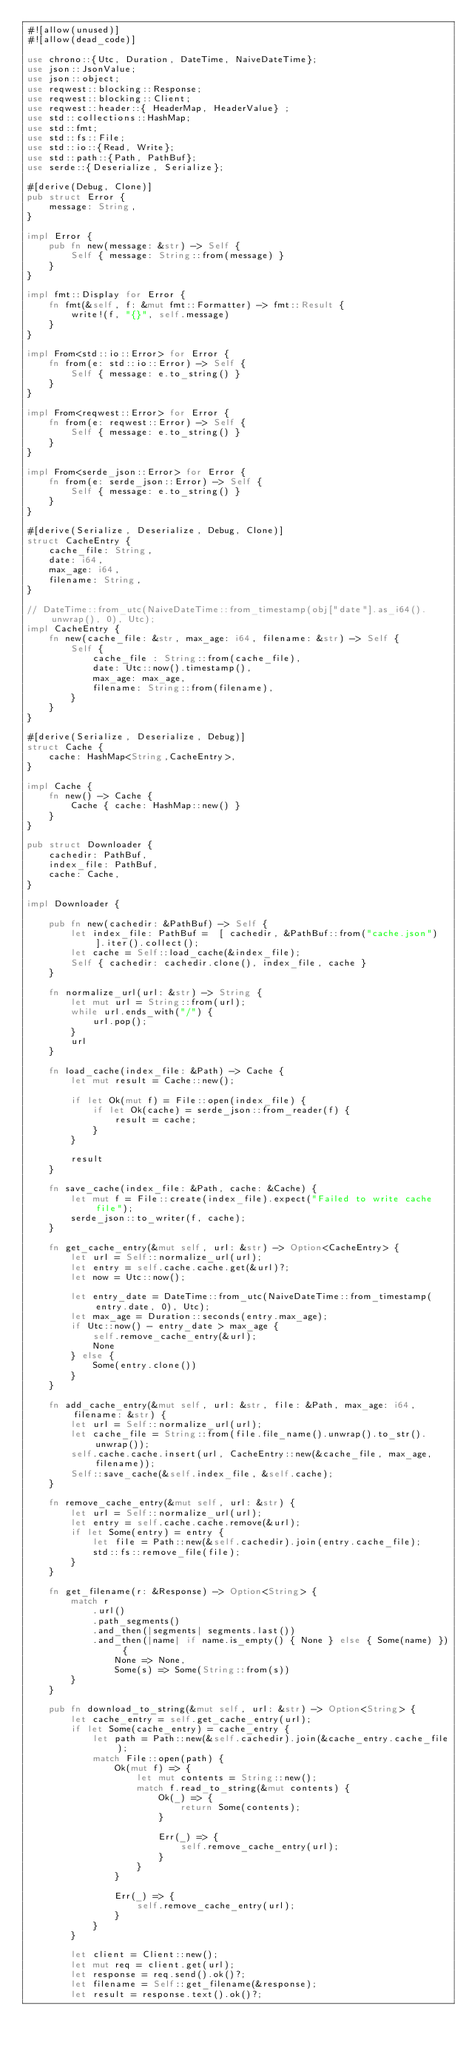Convert code to text. <code><loc_0><loc_0><loc_500><loc_500><_Rust_>#![allow(unused)]
#![allow(dead_code)]

use chrono::{Utc, Duration, DateTime, NaiveDateTime};
use json::JsonValue;
use json::object;
use reqwest::blocking::Response;
use reqwest::blocking::Client;
use reqwest::header::{ HeaderMap, HeaderValue} ;
use std::collections::HashMap;
use std::fmt;
use std::fs::File;
use std::io::{Read, Write};
use std::path::{Path, PathBuf};
use serde::{Deserialize, Serialize};

#[derive(Debug, Clone)]
pub struct Error {
    message: String,
}

impl Error {
    pub fn new(message: &str) -> Self {
        Self { message: String::from(message) }
    }
}

impl fmt::Display for Error {
    fn fmt(&self, f: &mut fmt::Formatter) -> fmt::Result {
        write!(f, "{}", self.message)
    }
}

impl From<std::io::Error> for Error {
    fn from(e: std::io::Error) -> Self {
        Self { message: e.to_string() }
    }
}

impl From<reqwest::Error> for Error {
    fn from(e: reqwest::Error) -> Self {
        Self { message: e.to_string() }
    }
}

impl From<serde_json::Error> for Error {
    fn from(e: serde_json::Error) -> Self {
        Self { message: e.to_string() }
    }
}

#[derive(Serialize, Deserialize, Debug, Clone)]
struct CacheEntry {
    cache_file: String,
    date: i64,
    max_age: i64,
    filename: String,
}

// DateTime::from_utc(NaiveDateTime::from_timestamp(obj["date"].as_i64().unwrap(), 0), Utc);
impl CacheEntry {
    fn new(cache_file: &str, max_age: i64, filename: &str) -> Self {
        Self {
            cache_file : String::from(cache_file),
            date: Utc::now().timestamp(),
            max_age: max_age,
            filename: String::from(filename),
        }
    }
}

#[derive(Serialize, Deserialize, Debug)]
struct Cache {
    cache: HashMap<String,CacheEntry>,
}

impl Cache {
    fn new() -> Cache {
        Cache { cache: HashMap::new() }
    }
}

pub struct Downloader {
    cachedir: PathBuf,
    index_file: PathBuf,
    cache: Cache,
}

impl Downloader {

    pub fn new(cachedir: &PathBuf) -> Self {
        let index_file: PathBuf =  [ cachedir, &PathBuf::from("cache.json") ].iter().collect();
        let cache = Self::load_cache(&index_file);
        Self { cachedir: cachedir.clone(), index_file, cache }
    }
    
    fn normalize_url(url: &str) -> String {
        let mut url = String::from(url);
        while url.ends_with("/") {
            url.pop();
        }
        url
    }

    fn load_cache(index_file: &Path) -> Cache {
        let mut result = Cache::new();

        if let Ok(mut f) = File::open(index_file) {
            if let Ok(cache) = serde_json::from_reader(f) {
                result = cache;
            }
        }

        result
    }

    fn save_cache(index_file: &Path, cache: &Cache) {
        let mut f = File::create(index_file).expect("Failed to write cache file");
        serde_json::to_writer(f, cache);
    }

    fn get_cache_entry(&mut self, url: &str) -> Option<CacheEntry> {
        let url = Self::normalize_url(url);
        let entry = self.cache.cache.get(&url)?;
        let now = Utc::now();

        let entry_date = DateTime::from_utc(NaiveDateTime::from_timestamp(entry.date, 0), Utc);
        let max_age = Duration::seconds(entry.max_age);
        if Utc::now() - entry_date > max_age {
            self.remove_cache_entry(&url);
            None
        } else {
            Some(entry.clone())
        }
    }

    fn add_cache_entry(&mut self, url: &str, file: &Path, max_age: i64, filename: &str) {
        let url = Self::normalize_url(url);
        let cache_file = String::from(file.file_name().unwrap().to_str().unwrap());
        self.cache.cache.insert(url, CacheEntry::new(&cache_file, max_age, filename));
        Self::save_cache(&self.index_file, &self.cache);
    }

    fn remove_cache_entry(&mut self, url: &str) {
        let url = Self::normalize_url(url);
        let entry = self.cache.cache.remove(&url);
        if let Some(entry) = entry {
            let file = Path::new(&self.cachedir).join(entry.cache_file);
            std::fs::remove_file(file);
        }
    }

    fn get_filename(r: &Response) -> Option<String> {
        match r
            .url()
            .path_segments()
            .and_then(|segments| segments.last())
            .and_then(|name| if name.is_empty() { None } else { Some(name) }) {
                None => None,
                Some(s) => Some(String::from(s))
        }
    }

    pub fn download_to_string(&mut self, url: &str) -> Option<String> {
        let cache_entry = self.get_cache_entry(url);
        if let Some(cache_entry) = cache_entry {
            let path = Path::new(&self.cachedir).join(&cache_entry.cache_file);
            match File::open(path) {
                Ok(mut f) => {
                    let mut contents = String::new();
                    match f.read_to_string(&mut contents) {
                        Ok(_) => {
                            return Some(contents);
                        }

                        Err(_) => {
                            self.remove_cache_entry(url);
                        }
                    }
                }

                Err(_) => {
                    self.remove_cache_entry(url);
                }
            }
        }

        let client = Client::new();
        let mut req = client.get(url);
        let response = req.send().ok()?;
        let filename = Self::get_filename(&response);
        let result = response.text().ok()?;</code> 